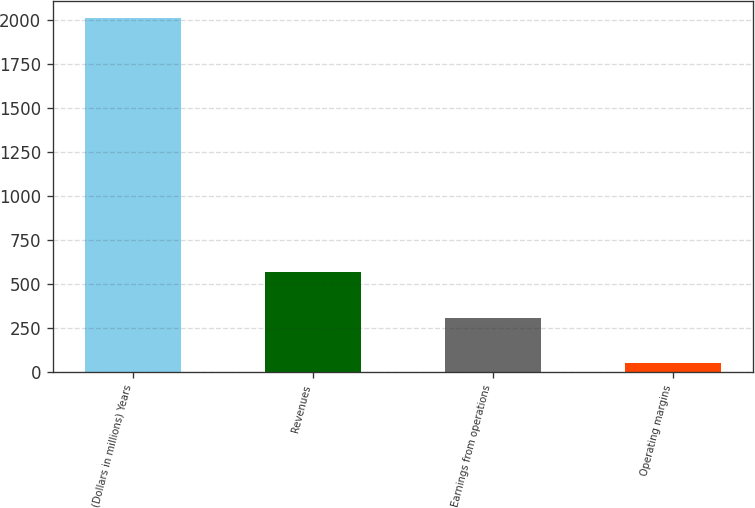Convert chart to OTSL. <chart><loc_0><loc_0><loc_500><loc_500><bar_chart><fcel>(Dollars in millions) Years<fcel>Revenues<fcel>Earnings from operations<fcel>Operating margins<nl><fcel>2008<fcel>567<fcel>307<fcel>54<nl></chart> 